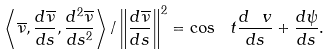Convert formula to latex. <formula><loc_0><loc_0><loc_500><loc_500>\left \langle \overline { \nu } , \frac { d \overline { \nu } } { d s } , \frac { d ^ { 2 } \overline { \nu } } { d s ^ { 2 } } \right \rangle / \left \| \frac { d \overline { \nu } } { d s } \right \| ^ { 2 } = \cos \ t \frac { d \ v } { d s } + \frac { d \psi } { d s } .</formula> 